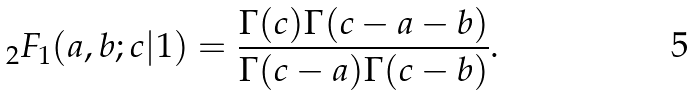<formula> <loc_0><loc_0><loc_500><loc_500>{ } _ { 2 } F _ { 1 } ( a , b ; c | 1 ) = \frac { \Gamma ( c ) \Gamma ( c - a - b ) } { \Gamma ( c - a ) \Gamma ( c - b ) } .</formula> 